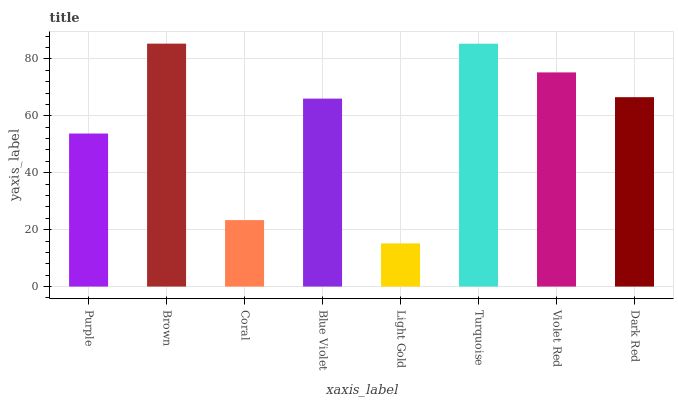Is Coral the minimum?
Answer yes or no. No. Is Coral the maximum?
Answer yes or no. No. Is Brown greater than Coral?
Answer yes or no. Yes. Is Coral less than Brown?
Answer yes or no. Yes. Is Coral greater than Brown?
Answer yes or no. No. Is Brown less than Coral?
Answer yes or no. No. Is Dark Red the high median?
Answer yes or no. Yes. Is Blue Violet the low median?
Answer yes or no. Yes. Is Purple the high median?
Answer yes or no. No. Is Light Gold the low median?
Answer yes or no. No. 